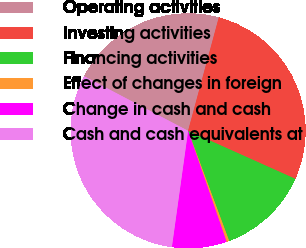Convert chart. <chart><loc_0><loc_0><loc_500><loc_500><pie_chart><fcel>Operating activities<fcel>Investing activities<fcel>Financing activities<fcel>Effect of changes in foreign<fcel>Change in cash and cash<fcel>Cash and cash equivalents at<nl><fcel>21.52%<fcel>27.5%<fcel>12.61%<fcel>0.37%<fcel>7.52%<fcel>30.49%<nl></chart> 